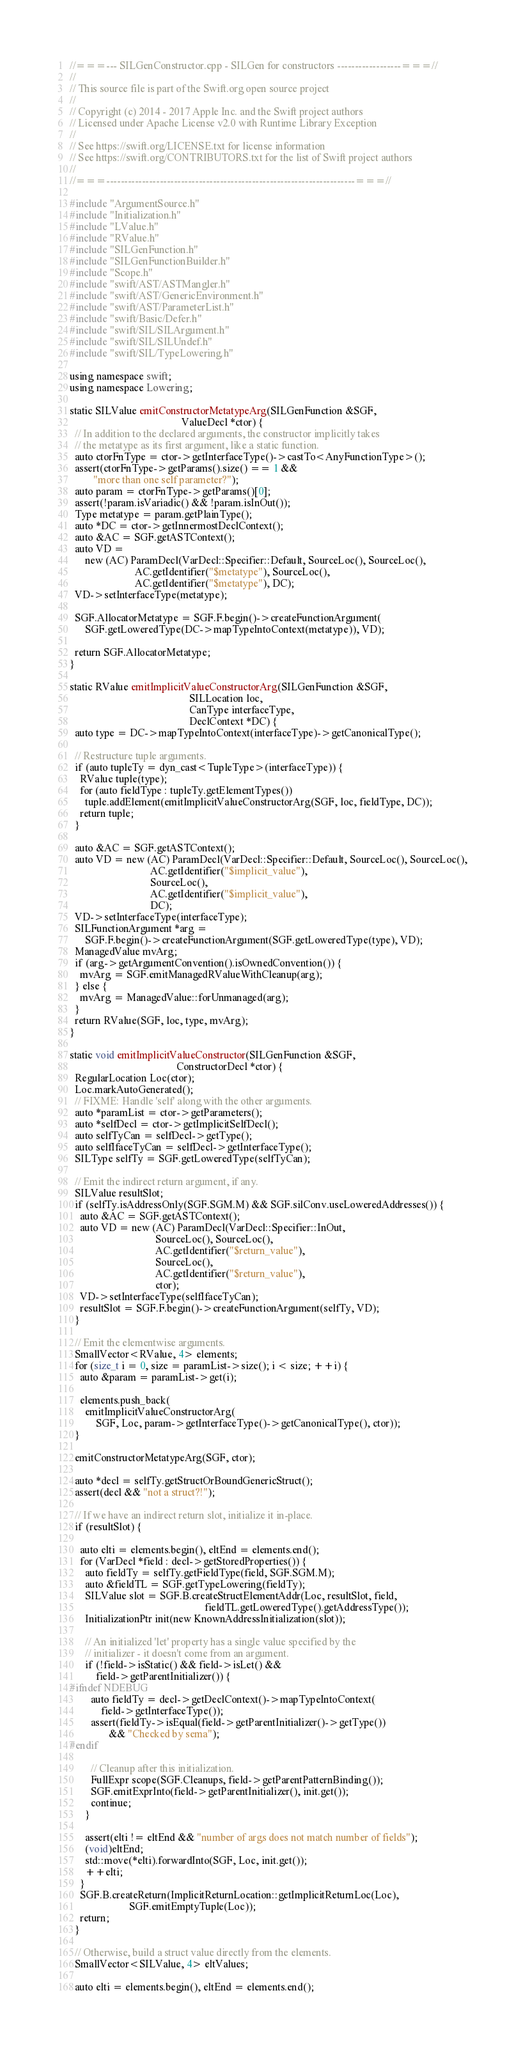<code> <loc_0><loc_0><loc_500><loc_500><_C++_>//===--- SILGenConstructor.cpp - SILGen for constructors ------------------===//
//
// This source file is part of the Swift.org open source project
//
// Copyright (c) 2014 - 2017 Apple Inc. and the Swift project authors
// Licensed under Apache License v2.0 with Runtime Library Exception
//
// See https://swift.org/LICENSE.txt for license information
// See https://swift.org/CONTRIBUTORS.txt for the list of Swift project authors
//
//===----------------------------------------------------------------------===//

#include "ArgumentSource.h"
#include "Initialization.h"
#include "LValue.h"
#include "RValue.h"
#include "SILGenFunction.h"
#include "SILGenFunctionBuilder.h"
#include "Scope.h"
#include "swift/AST/ASTMangler.h"
#include "swift/AST/GenericEnvironment.h"
#include "swift/AST/ParameterList.h"
#include "swift/Basic/Defer.h"
#include "swift/SIL/SILArgument.h"
#include "swift/SIL/SILUndef.h"
#include "swift/SIL/TypeLowering.h"

using namespace swift;
using namespace Lowering;

static SILValue emitConstructorMetatypeArg(SILGenFunction &SGF,
                                           ValueDecl *ctor) {
  // In addition to the declared arguments, the constructor implicitly takes
  // the metatype as its first argument, like a static function.
  auto ctorFnType = ctor->getInterfaceType()->castTo<AnyFunctionType>();
  assert(ctorFnType->getParams().size() == 1 &&
         "more than one self parameter?");
  auto param = ctorFnType->getParams()[0];
  assert(!param.isVariadic() && !param.isInOut());
  Type metatype = param.getPlainType();
  auto *DC = ctor->getInnermostDeclContext();
  auto &AC = SGF.getASTContext();
  auto VD =
      new (AC) ParamDecl(VarDecl::Specifier::Default, SourceLoc(), SourceLoc(),
                         AC.getIdentifier("$metatype"), SourceLoc(),
                         AC.getIdentifier("$metatype"), DC);
  VD->setInterfaceType(metatype);

  SGF.AllocatorMetatype = SGF.F.begin()->createFunctionArgument(
      SGF.getLoweredType(DC->mapTypeIntoContext(metatype)), VD);

  return SGF.AllocatorMetatype;
}

static RValue emitImplicitValueConstructorArg(SILGenFunction &SGF,
                                              SILLocation loc,
                                              CanType interfaceType,
                                              DeclContext *DC) {
  auto type = DC->mapTypeIntoContext(interfaceType)->getCanonicalType();

  // Restructure tuple arguments.
  if (auto tupleTy = dyn_cast<TupleType>(interfaceType)) {
    RValue tuple(type);
    for (auto fieldType : tupleTy.getElementTypes())
      tuple.addElement(emitImplicitValueConstructorArg(SGF, loc, fieldType, DC));
    return tuple;
  }

  auto &AC = SGF.getASTContext();
  auto VD = new (AC) ParamDecl(VarDecl::Specifier::Default, SourceLoc(), SourceLoc(),
                               AC.getIdentifier("$implicit_value"),
                               SourceLoc(),
                               AC.getIdentifier("$implicit_value"),
                               DC);
  VD->setInterfaceType(interfaceType);
  SILFunctionArgument *arg =
      SGF.F.begin()->createFunctionArgument(SGF.getLoweredType(type), VD);
  ManagedValue mvArg;
  if (arg->getArgumentConvention().isOwnedConvention()) {
    mvArg = SGF.emitManagedRValueWithCleanup(arg);
  } else {
    mvArg = ManagedValue::forUnmanaged(arg);
  }
  return RValue(SGF, loc, type, mvArg);
}

static void emitImplicitValueConstructor(SILGenFunction &SGF,
                                         ConstructorDecl *ctor) {
  RegularLocation Loc(ctor);
  Loc.markAutoGenerated();
  // FIXME: Handle 'self' along with the other arguments.
  auto *paramList = ctor->getParameters();
  auto *selfDecl = ctor->getImplicitSelfDecl();
  auto selfTyCan = selfDecl->getType();
  auto selfIfaceTyCan = selfDecl->getInterfaceType();
  SILType selfTy = SGF.getLoweredType(selfTyCan);

  // Emit the indirect return argument, if any.
  SILValue resultSlot;
  if (selfTy.isAddressOnly(SGF.SGM.M) && SGF.silConv.useLoweredAddresses()) {
    auto &AC = SGF.getASTContext();
    auto VD = new (AC) ParamDecl(VarDecl::Specifier::InOut,
                                 SourceLoc(), SourceLoc(),
                                 AC.getIdentifier("$return_value"),
                                 SourceLoc(),
                                 AC.getIdentifier("$return_value"),
                                 ctor);
    VD->setInterfaceType(selfIfaceTyCan);
    resultSlot = SGF.F.begin()->createFunctionArgument(selfTy, VD);
  }

  // Emit the elementwise arguments.
  SmallVector<RValue, 4> elements;
  for (size_t i = 0, size = paramList->size(); i < size; ++i) {
    auto &param = paramList->get(i);

    elements.push_back(
      emitImplicitValueConstructorArg(
          SGF, Loc, param->getInterfaceType()->getCanonicalType(), ctor));
  }

  emitConstructorMetatypeArg(SGF, ctor);

  auto *decl = selfTy.getStructOrBoundGenericStruct();
  assert(decl && "not a struct?!");

  // If we have an indirect return slot, initialize it in-place.
  if (resultSlot) {

    auto elti = elements.begin(), eltEnd = elements.end();
    for (VarDecl *field : decl->getStoredProperties()) {
      auto fieldTy = selfTy.getFieldType(field, SGF.SGM.M);
      auto &fieldTL = SGF.getTypeLowering(fieldTy);
      SILValue slot = SGF.B.createStructElementAddr(Loc, resultSlot, field,
                                                    fieldTL.getLoweredType().getAddressType());
      InitializationPtr init(new KnownAddressInitialization(slot));

      // An initialized 'let' property has a single value specified by the
      // initializer - it doesn't come from an argument.
      if (!field->isStatic() && field->isLet() &&
          field->getParentInitializer()) {
#ifndef NDEBUG
        auto fieldTy = decl->getDeclContext()->mapTypeIntoContext(
            field->getInterfaceType());
        assert(fieldTy->isEqual(field->getParentInitializer()->getType())
               && "Checked by sema");
#endif

        // Cleanup after this initialization.
        FullExpr scope(SGF.Cleanups, field->getParentPatternBinding());
        SGF.emitExprInto(field->getParentInitializer(), init.get());
        continue;
      }

      assert(elti != eltEnd && "number of args does not match number of fields");
      (void)eltEnd;
      std::move(*elti).forwardInto(SGF, Loc, init.get());
      ++elti;
    }
    SGF.B.createReturn(ImplicitReturnLocation::getImplicitReturnLoc(Loc),
                       SGF.emitEmptyTuple(Loc));
    return;
  }

  // Otherwise, build a struct value directly from the elements.
  SmallVector<SILValue, 4> eltValues;

  auto elti = elements.begin(), eltEnd = elements.end();</code> 